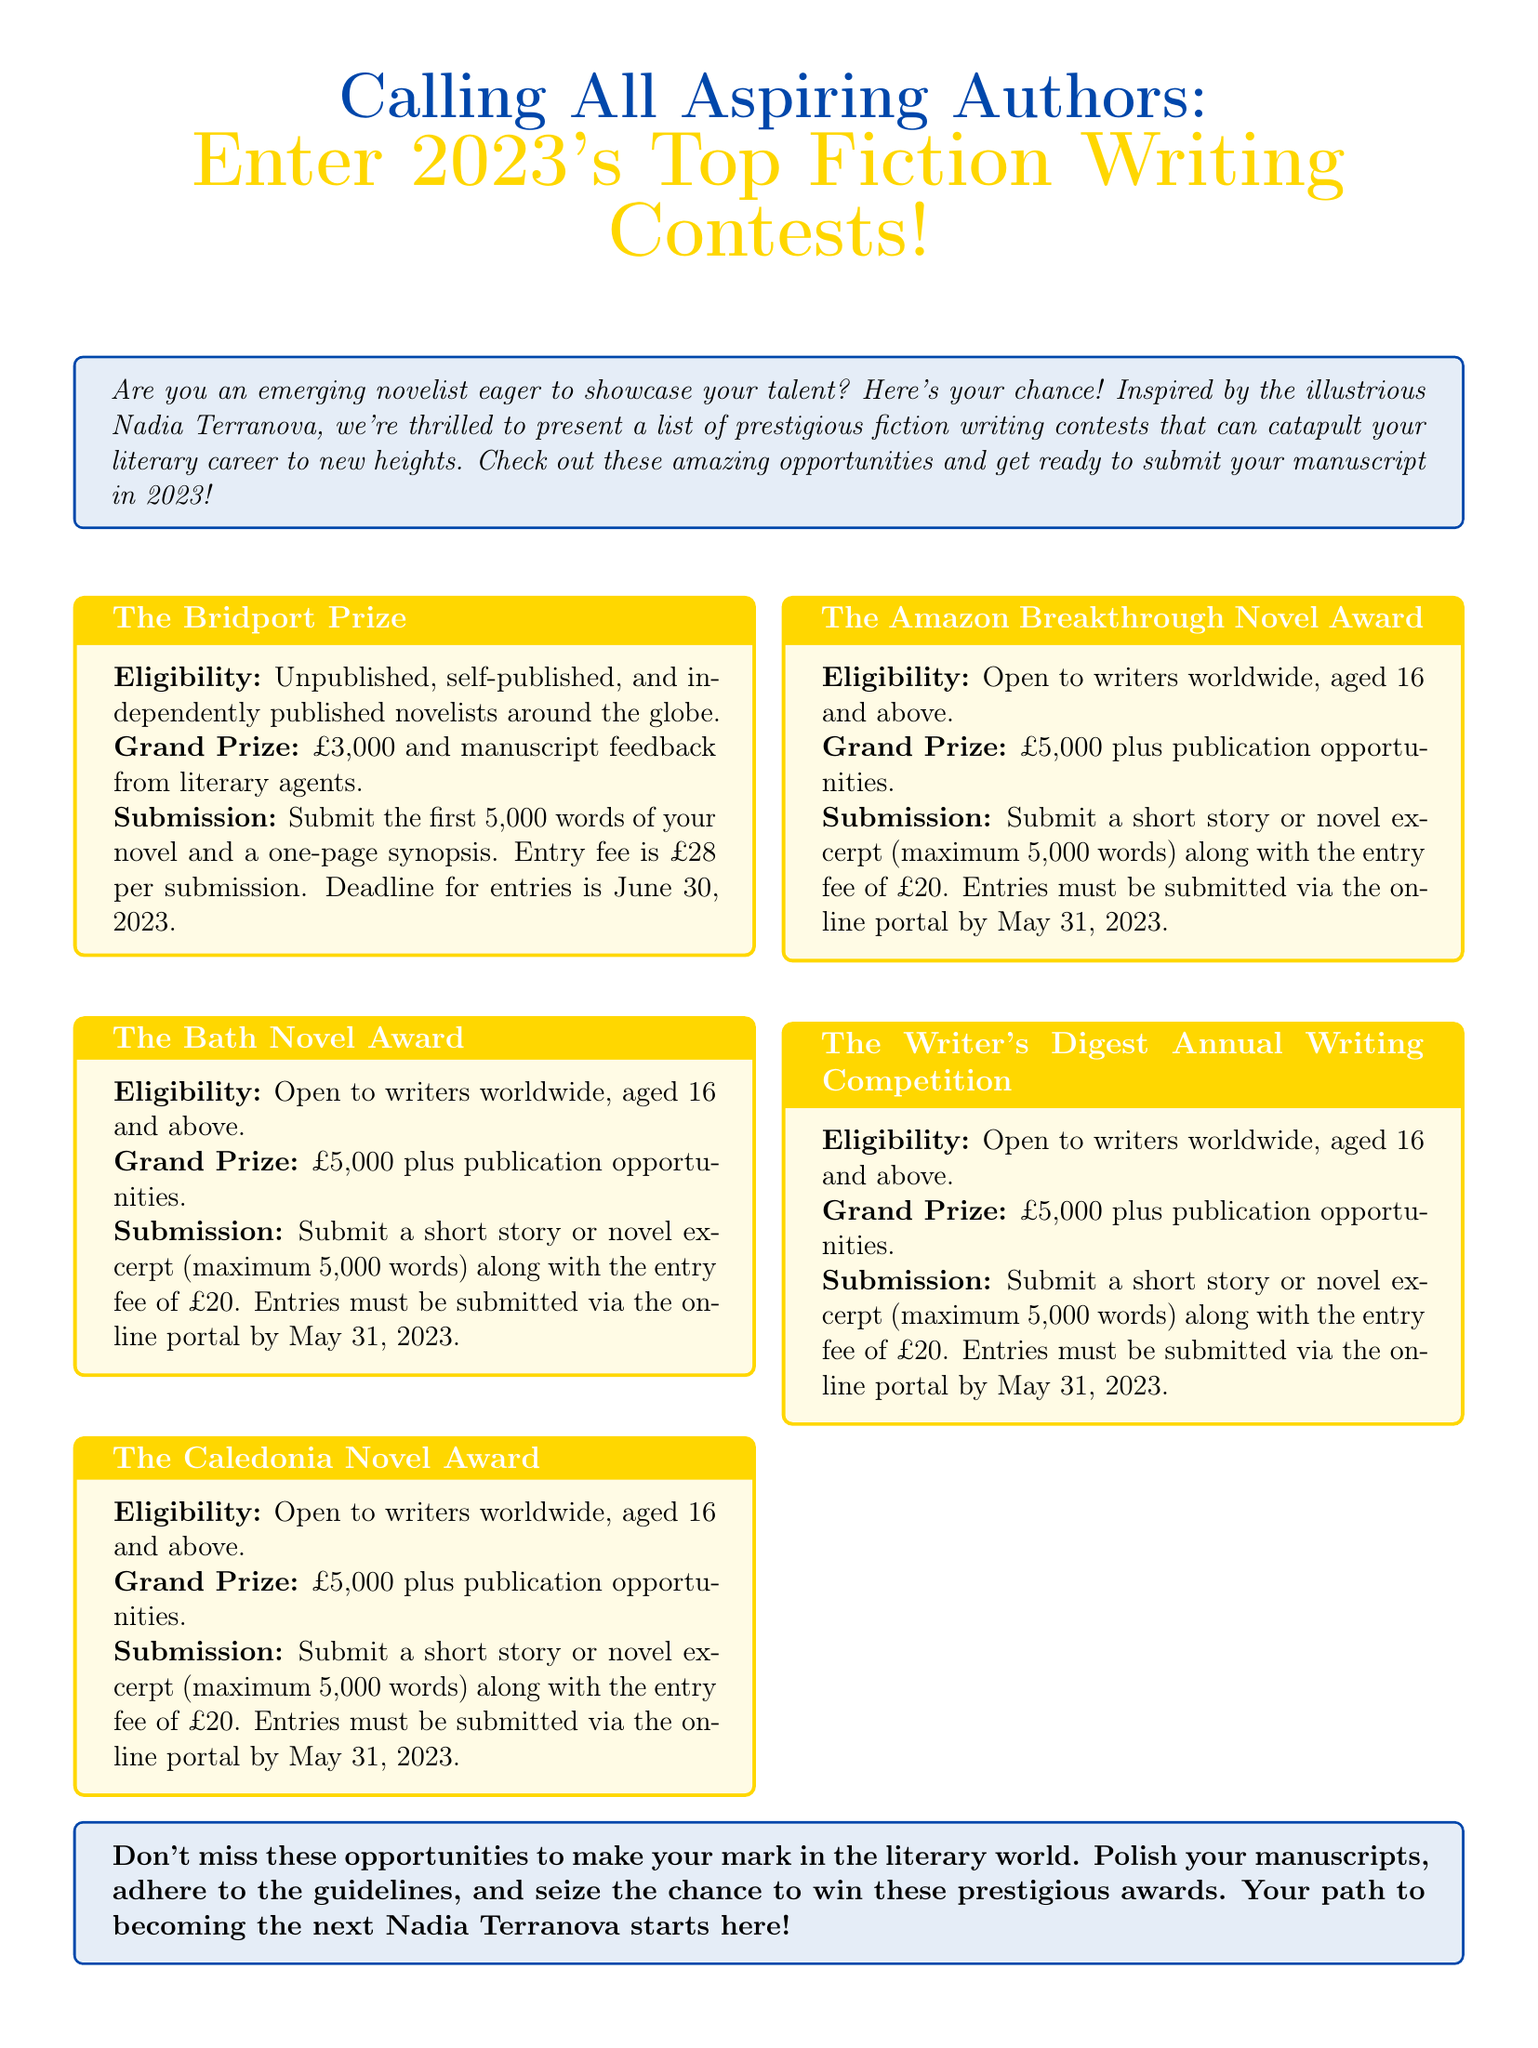what is the prize for The Bridport Prize? The prize for The Bridport Prize is £5,000 plus publication opportunities.
Answer: £5,000 plus publication opportunities what is the entry fee for The Bath Novel Award? The entry fee for The Bath Novel Award is £28 per submission.
Answer: £28 what is the submission deadline for The Caledonia Novel Award? The submission deadline for The Caledonia Novel Award is November 1, 2023.
Answer: November 1, 2023 who is eligible for The Amazon Breakthrough Novel Award? The Amazon Breakthrough Novel Award is open to authors with a complete novel manuscript in English (50,000-125,000 words).
Answer: Authors with a complete novel manuscript what is the maximum word count for The Writer's Digest Annual Writing Competition? The maximum word count for The Writer's Digest Annual Writing Competition is up to 4,000 words.
Answer: up to 4,000 words which contest offers an introduction to literary agents as a prize? The contest that offers an introduction to literary agents as a prize is The Caledonia Novel Award.
Answer: The Caledonia Novel Award what type of submission is required for The Bridport Prize? The Bridport Prize requires a short story or novel excerpt (maximum 5,000 words).
Answer: a short story or novel excerpt how many contests are highlighted in the advertisement? There are five contests highlighted in the advertisement.
Answer: five contests 